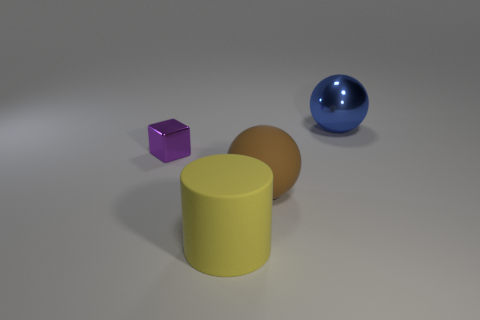Is there anything else that is the same size as the purple block?
Your answer should be compact. No. There is another big thing that is the same shape as the blue thing; what color is it?
Ensure brevity in your answer.  Brown. How many shiny spheres are in front of the big brown sphere right of the thing that is in front of the brown object?
Offer a very short reply. 0. Are there fewer large spheres that are in front of the large matte ball than big blue spheres?
Provide a succinct answer. Yes. What size is the blue object that is the same shape as the brown rubber object?
Provide a short and direct response. Large. What number of big cyan blocks are made of the same material as the purple object?
Keep it short and to the point. 0. Are the large ball that is to the left of the large metallic sphere and the purple object made of the same material?
Your response must be concise. No. Are there an equal number of large brown matte objects that are left of the brown matte ball and gray rubber balls?
Offer a terse response. Yes. What size is the brown matte thing?
Ensure brevity in your answer.  Large. What number of cubes have the same color as the small metal object?
Make the answer very short. 0. 